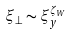<formula> <loc_0><loc_0><loc_500><loc_500>\xi _ { \perp } \sim \xi _ { y } ^ { \zeta _ { W } }</formula> 